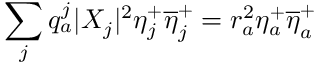<formula> <loc_0><loc_0><loc_500><loc_500>\sum _ { j } q _ { a } ^ { j } | X _ { j } | ^ { 2 } \eta _ { j } ^ { + } \overline { \eta } _ { j } ^ { + } = r _ { a } ^ { 2 } \eta _ { a } ^ { + } \overline { \eta } _ { a } ^ { + }</formula> 